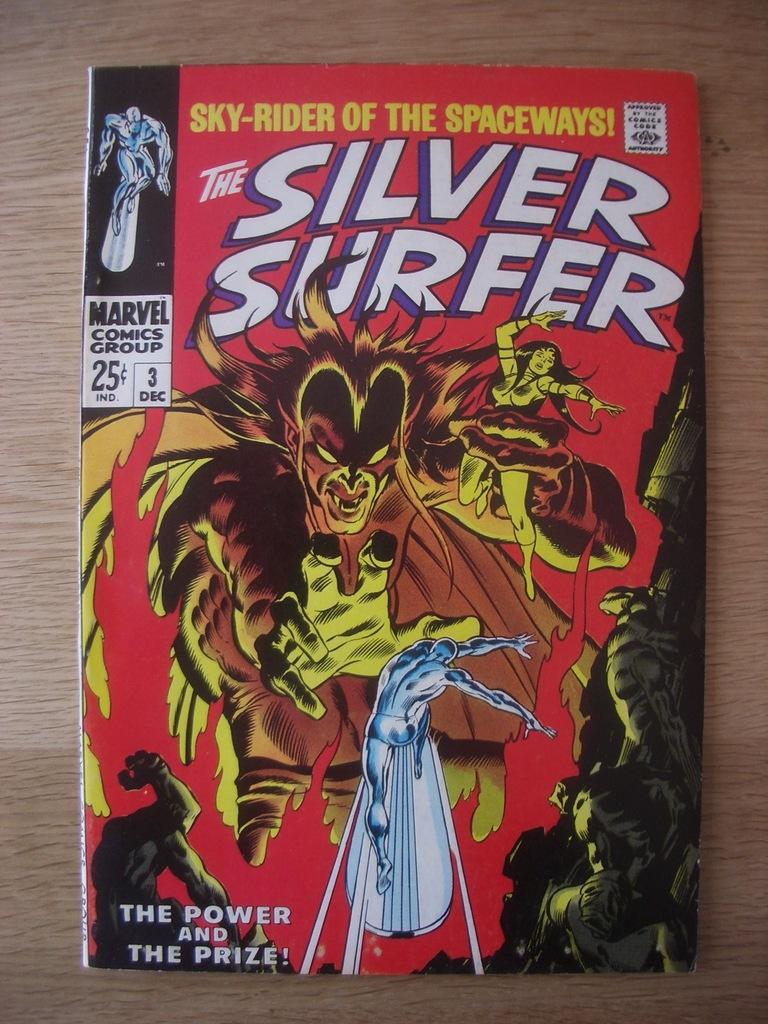<image>
Present a compact description of the photo's key features. The red comic book is The Silver Surfer 